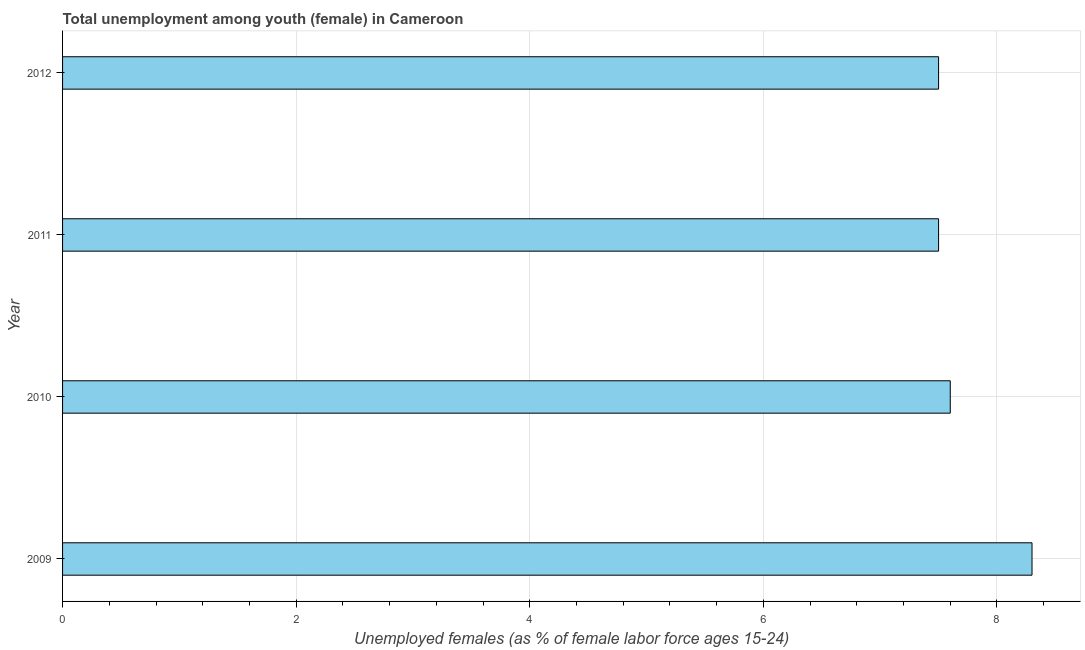Does the graph contain any zero values?
Your answer should be compact. No. What is the title of the graph?
Keep it short and to the point. Total unemployment among youth (female) in Cameroon. What is the label or title of the X-axis?
Your answer should be very brief. Unemployed females (as % of female labor force ages 15-24). What is the unemployed female youth population in 2010?
Your answer should be very brief. 7.6. Across all years, what is the maximum unemployed female youth population?
Give a very brief answer. 8.3. Across all years, what is the minimum unemployed female youth population?
Your response must be concise. 7.5. In which year was the unemployed female youth population maximum?
Make the answer very short. 2009. What is the sum of the unemployed female youth population?
Your answer should be very brief. 30.9. What is the average unemployed female youth population per year?
Give a very brief answer. 7.72. What is the median unemployed female youth population?
Your answer should be very brief. 7.55. Do a majority of the years between 2011 and 2012 (inclusive) have unemployed female youth population greater than 6 %?
Offer a terse response. Yes. Is the sum of the unemployed female youth population in 2010 and 2011 greater than the maximum unemployed female youth population across all years?
Your answer should be very brief. Yes. What is the difference between the highest and the lowest unemployed female youth population?
Your answer should be compact. 0.8. How many years are there in the graph?
Your answer should be compact. 4. What is the Unemployed females (as % of female labor force ages 15-24) in 2009?
Offer a terse response. 8.3. What is the Unemployed females (as % of female labor force ages 15-24) of 2010?
Offer a terse response. 7.6. What is the Unemployed females (as % of female labor force ages 15-24) in 2011?
Provide a short and direct response. 7.5. What is the Unemployed females (as % of female labor force ages 15-24) of 2012?
Keep it short and to the point. 7.5. What is the difference between the Unemployed females (as % of female labor force ages 15-24) in 2009 and 2011?
Ensure brevity in your answer.  0.8. What is the difference between the Unemployed females (as % of female labor force ages 15-24) in 2009 and 2012?
Offer a terse response. 0.8. What is the difference between the Unemployed females (as % of female labor force ages 15-24) in 2010 and 2011?
Offer a very short reply. 0.1. What is the difference between the Unemployed females (as % of female labor force ages 15-24) in 2011 and 2012?
Provide a succinct answer. 0. What is the ratio of the Unemployed females (as % of female labor force ages 15-24) in 2009 to that in 2010?
Offer a terse response. 1.09. What is the ratio of the Unemployed females (as % of female labor force ages 15-24) in 2009 to that in 2011?
Provide a short and direct response. 1.11. What is the ratio of the Unemployed females (as % of female labor force ages 15-24) in 2009 to that in 2012?
Keep it short and to the point. 1.11. What is the ratio of the Unemployed females (as % of female labor force ages 15-24) in 2010 to that in 2011?
Your response must be concise. 1.01. 